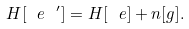Convert formula to latex. <formula><loc_0><loc_0><loc_500><loc_500>H [ \ e \ ^ { \prime } ] = H [ \ e ] + n [ g ] .</formula> 